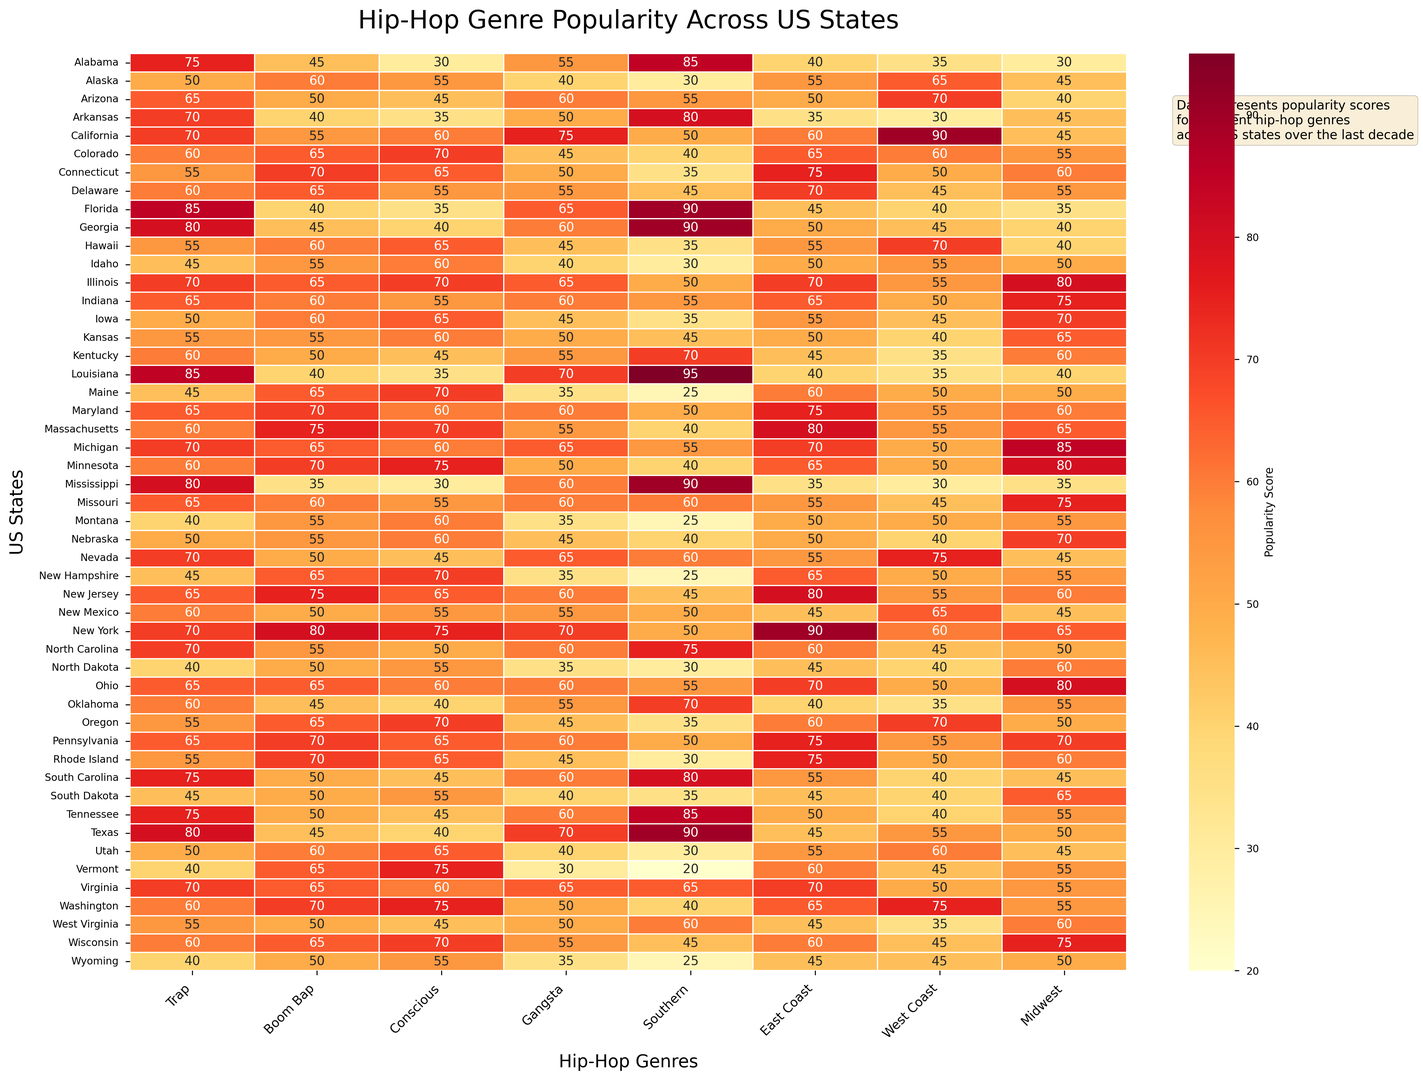Which state shows the highest popularity for Trap music? In the heatmap, find the state with the highest value in the "Trap" column. The highest value (85) is present for Florida, Louisiana, and Texas.
Answer: Florida, Louisiana, Texas Which genre is the most popular in California? In the heatmap, locate the row for California and find the genre with the highest score. The highest popularity score for California is 90, which corresponds to the "West Coast" genre.
Answer: West Coast What's the average popularity of Boom Bap music across all states? Sum all the values in the "Boom Bap" column and divide by the number of states (50). The total sum is 3115, so the average is 3115/50 = 62.3.
Answer: 62.3 Which two states have the same popularity score for Gangsta music? Look for identical values in the "Gangsta" column. Both New York and Michigan show a popularity score of 70.
Answer: New York, Michigan Which genre shows a uniform popularity score across Idaho? In the heatmap, check the Idaho row for any column where the score remains constant. The values are different across all genres; hence, none have uniform popularity.
Answer: None How does the popularity of East Coast music in New Jersey compare to Florida? Look at the "East Coast" column; New Jersey has a score of 80, while Florida has a score of 45. New Jersey's popularity for East Coast music is greater than Florida's.
Answer: Higher Which genre has the lowest popularity score in Alaska and what is its value? Find the lowest value in the Alaska row. The lowest score is 30, corresponding to the "Southern" genre.
Answer: Southern, 30 What is the median popularity score for Conscious music across all states? List all the values in the "Conscious" column, sort them, and find the middle value (or average of two middle values). The sorted values indicate a median of 55.
Answer: 55 Which state has the highest combined score for Southern and West Coast genres? Sum the values for "Southern" and "West Coast" columns for all states and identify the highest combined score. Texas scores 90 (Southern) + 55 (West Coast) = 145, which is the highest.
Answer: Texas How did the popularity of Midwest hip-hop change from 2010 to 2020 in Illinois? Compare the values in the "Midwest" column for Illinois in the years 2010 (75) and 2020 (85). The popularity increased by 85 - 75 = 10 points.
Answer: Increased by 10 points 